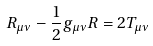Convert formula to latex. <formula><loc_0><loc_0><loc_500><loc_500>R _ { \mu \nu } - \frac { 1 } { 2 } g _ { \mu \nu } R = 2 T _ { \mu \nu }</formula> 